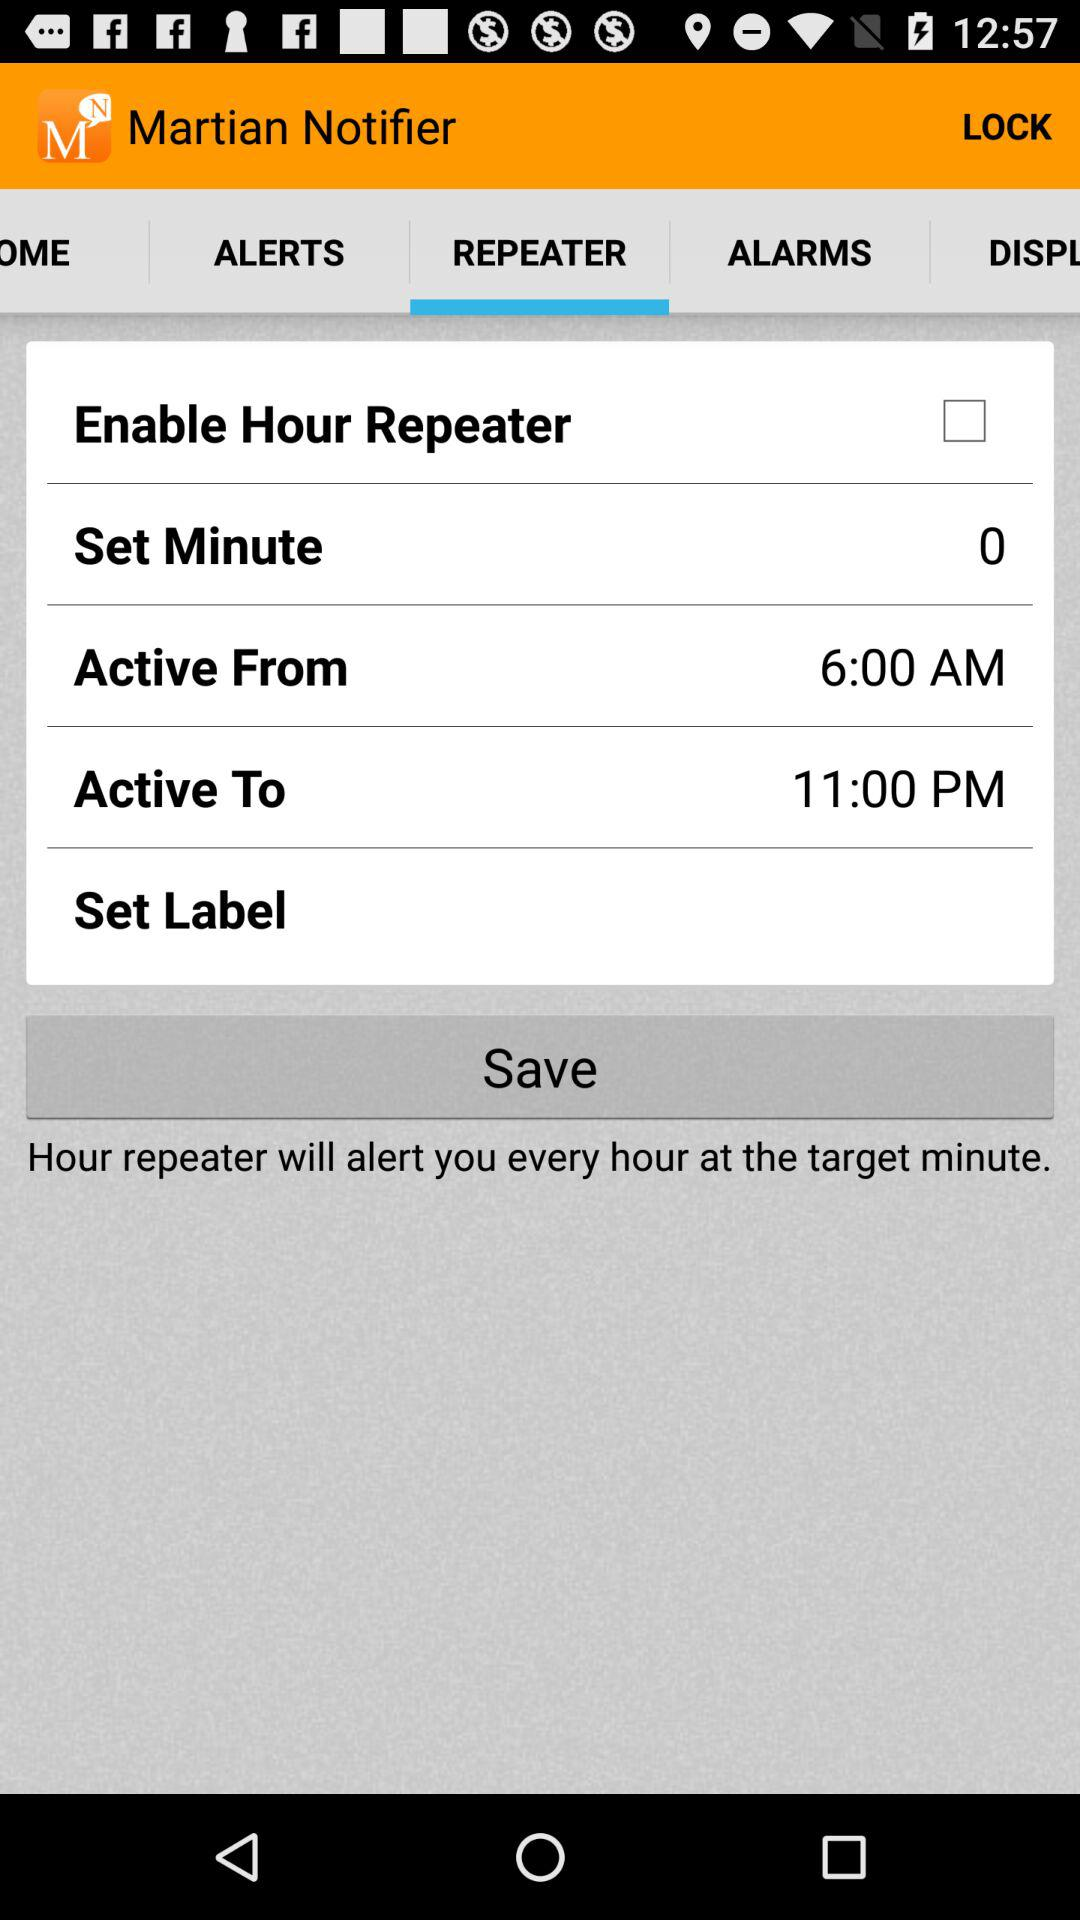What is the status of the "Enable Hour Repeater"? The status is off. 